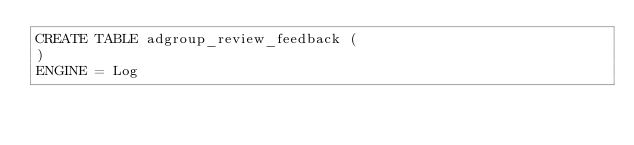<code> <loc_0><loc_0><loc_500><loc_500><_SQL_>CREATE TABLE adgroup_review_feedback (
)
ENGINE = Log
</code> 